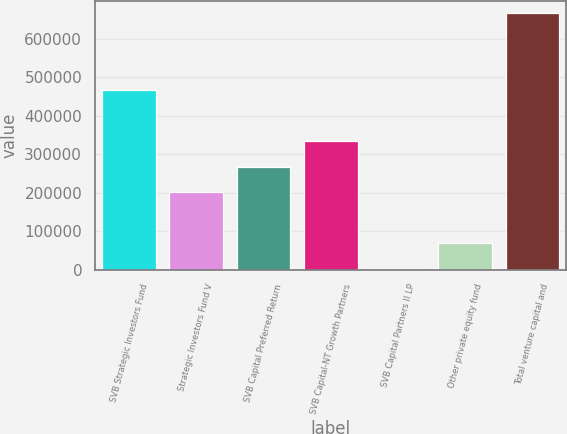Convert chart. <chart><loc_0><loc_0><loc_500><loc_500><bar_chart><fcel>SVB Strategic Investors Fund<fcel>Strategic Investors Fund V<fcel>SVB Capital Preferred Return<fcel>SVB Capital-NT Growth Partners<fcel>SVB Capital Partners II LP<fcel>Other private equity fund<fcel>Total venture capital and<nl><fcel>466536<fcel>200688<fcel>267150<fcel>333612<fcel>1303<fcel>67764.8<fcel>665921<nl></chart> 